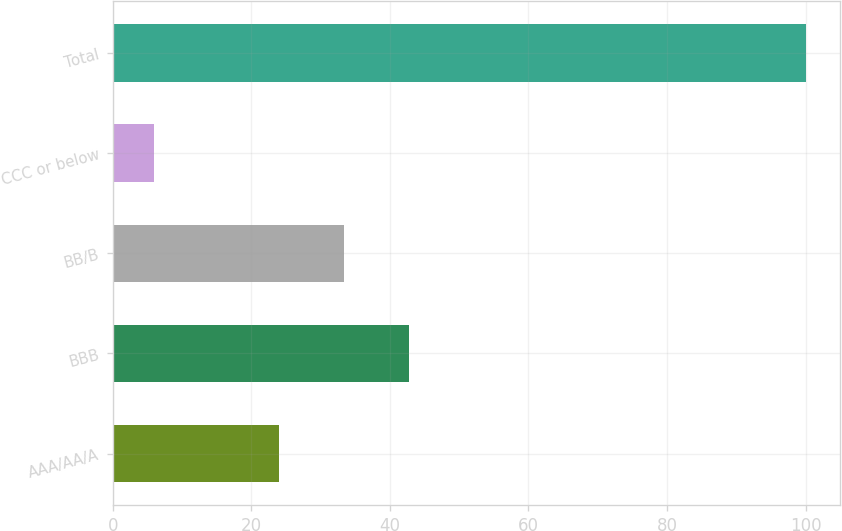<chart> <loc_0><loc_0><loc_500><loc_500><bar_chart><fcel>AAA/AA/A<fcel>BBB<fcel>BB/B<fcel>CCC or below<fcel>Total<nl><fcel>24<fcel>42.8<fcel>33.4<fcel>6<fcel>100<nl></chart> 